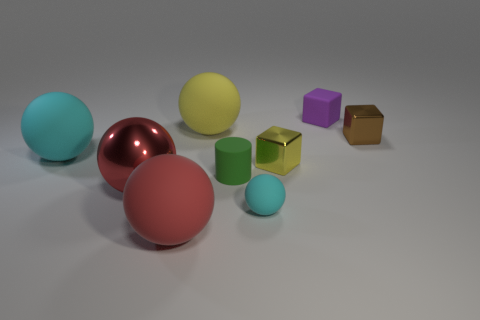There is a purple cube that is the same size as the green cylinder; what is it made of?
Keep it short and to the point. Rubber. What color is the cylinder?
Provide a short and direct response. Green. There is a thing that is both in front of the cylinder and on the right side of the big yellow rubber ball; what material is it?
Your answer should be compact. Rubber. There is a red rubber sphere that is in front of the tiny metal thing behind the large cyan thing; are there any yellow objects that are left of it?
Make the answer very short. No. There is a thing that is the same color as the metallic sphere; what size is it?
Keep it short and to the point. Large. Are there any red objects on the right side of the large red shiny thing?
Provide a short and direct response. Yes. What number of other objects are the same shape as the small cyan object?
Give a very brief answer. 4. The matte ball that is the same size as the yellow metallic cube is what color?
Give a very brief answer. Cyan. Are there fewer large red things that are in front of the large red matte sphere than small cubes on the right side of the brown cube?
Your response must be concise. No. What number of cylinders are left of the cube left of the object that is behind the large yellow sphere?
Your response must be concise. 1. 